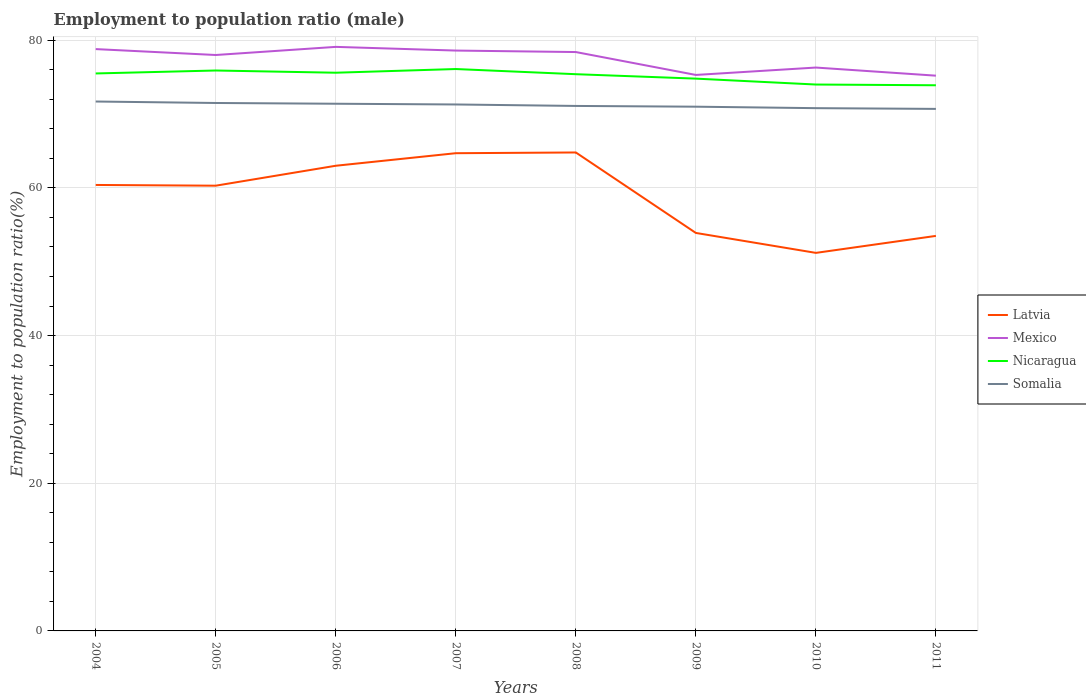Is the number of lines equal to the number of legend labels?
Your response must be concise. Yes. Across all years, what is the maximum employment to population ratio in Mexico?
Provide a succinct answer. 75.2. In which year was the employment to population ratio in Mexico maximum?
Offer a terse response. 2011. What is the total employment to population ratio in Somalia in the graph?
Provide a short and direct response. 0.3. What is the difference between the highest and the second highest employment to population ratio in Nicaragua?
Make the answer very short. 2.2. What is the difference between the highest and the lowest employment to population ratio in Mexico?
Provide a succinct answer. 5. Is the employment to population ratio in Mexico strictly greater than the employment to population ratio in Nicaragua over the years?
Give a very brief answer. No. What is the difference between two consecutive major ticks on the Y-axis?
Ensure brevity in your answer.  20. Are the values on the major ticks of Y-axis written in scientific E-notation?
Keep it short and to the point. No. Does the graph contain any zero values?
Provide a succinct answer. No. Where does the legend appear in the graph?
Offer a terse response. Center right. How are the legend labels stacked?
Provide a short and direct response. Vertical. What is the title of the graph?
Your response must be concise. Employment to population ratio (male). Does "Korea (Republic)" appear as one of the legend labels in the graph?
Give a very brief answer. No. What is the label or title of the Y-axis?
Offer a terse response. Employment to population ratio(%). What is the Employment to population ratio(%) of Latvia in 2004?
Ensure brevity in your answer.  60.4. What is the Employment to population ratio(%) of Mexico in 2004?
Keep it short and to the point. 78.8. What is the Employment to population ratio(%) of Nicaragua in 2004?
Offer a terse response. 75.5. What is the Employment to population ratio(%) in Somalia in 2004?
Provide a succinct answer. 71.7. What is the Employment to population ratio(%) of Latvia in 2005?
Keep it short and to the point. 60.3. What is the Employment to population ratio(%) of Nicaragua in 2005?
Provide a succinct answer. 75.9. What is the Employment to population ratio(%) of Somalia in 2005?
Offer a very short reply. 71.5. What is the Employment to population ratio(%) in Latvia in 2006?
Provide a succinct answer. 63. What is the Employment to population ratio(%) of Mexico in 2006?
Your answer should be very brief. 79.1. What is the Employment to population ratio(%) in Nicaragua in 2006?
Your answer should be very brief. 75.6. What is the Employment to population ratio(%) of Somalia in 2006?
Keep it short and to the point. 71.4. What is the Employment to population ratio(%) of Latvia in 2007?
Your answer should be compact. 64.7. What is the Employment to population ratio(%) in Mexico in 2007?
Provide a short and direct response. 78.6. What is the Employment to population ratio(%) in Nicaragua in 2007?
Offer a terse response. 76.1. What is the Employment to population ratio(%) in Somalia in 2007?
Your response must be concise. 71.3. What is the Employment to population ratio(%) in Latvia in 2008?
Provide a short and direct response. 64.8. What is the Employment to population ratio(%) of Mexico in 2008?
Keep it short and to the point. 78.4. What is the Employment to population ratio(%) of Nicaragua in 2008?
Offer a terse response. 75.4. What is the Employment to population ratio(%) in Somalia in 2008?
Your response must be concise. 71.1. What is the Employment to population ratio(%) in Latvia in 2009?
Make the answer very short. 53.9. What is the Employment to population ratio(%) in Mexico in 2009?
Offer a very short reply. 75.3. What is the Employment to population ratio(%) of Nicaragua in 2009?
Your response must be concise. 74.8. What is the Employment to population ratio(%) in Somalia in 2009?
Your response must be concise. 71. What is the Employment to population ratio(%) in Latvia in 2010?
Ensure brevity in your answer.  51.2. What is the Employment to population ratio(%) in Mexico in 2010?
Your response must be concise. 76.3. What is the Employment to population ratio(%) of Somalia in 2010?
Give a very brief answer. 70.8. What is the Employment to population ratio(%) in Latvia in 2011?
Your answer should be compact. 53.5. What is the Employment to population ratio(%) of Mexico in 2011?
Your answer should be compact. 75.2. What is the Employment to population ratio(%) of Nicaragua in 2011?
Offer a very short reply. 73.9. What is the Employment to population ratio(%) of Somalia in 2011?
Provide a short and direct response. 70.7. Across all years, what is the maximum Employment to population ratio(%) of Latvia?
Your answer should be compact. 64.8. Across all years, what is the maximum Employment to population ratio(%) of Mexico?
Give a very brief answer. 79.1. Across all years, what is the maximum Employment to population ratio(%) in Nicaragua?
Give a very brief answer. 76.1. Across all years, what is the maximum Employment to population ratio(%) of Somalia?
Your answer should be compact. 71.7. Across all years, what is the minimum Employment to population ratio(%) of Latvia?
Give a very brief answer. 51.2. Across all years, what is the minimum Employment to population ratio(%) of Mexico?
Your answer should be compact. 75.2. Across all years, what is the minimum Employment to population ratio(%) in Nicaragua?
Your answer should be compact. 73.9. Across all years, what is the minimum Employment to population ratio(%) of Somalia?
Make the answer very short. 70.7. What is the total Employment to population ratio(%) of Latvia in the graph?
Your answer should be compact. 471.8. What is the total Employment to population ratio(%) in Mexico in the graph?
Ensure brevity in your answer.  619.7. What is the total Employment to population ratio(%) in Nicaragua in the graph?
Offer a very short reply. 601.2. What is the total Employment to population ratio(%) of Somalia in the graph?
Your answer should be compact. 569.5. What is the difference between the Employment to population ratio(%) of Latvia in 2004 and that in 2005?
Ensure brevity in your answer.  0.1. What is the difference between the Employment to population ratio(%) of Mexico in 2004 and that in 2005?
Your answer should be compact. 0.8. What is the difference between the Employment to population ratio(%) of Nicaragua in 2004 and that in 2005?
Provide a short and direct response. -0.4. What is the difference between the Employment to population ratio(%) of Somalia in 2004 and that in 2005?
Offer a very short reply. 0.2. What is the difference between the Employment to population ratio(%) in Nicaragua in 2004 and that in 2006?
Your answer should be very brief. -0.1. What is the difference between the Employment to population ratio(%) in Somalia in 2004 and that in 2006?
Make the answer very short. 0.3. What is the difference between the Employment to population ratio(%) of Nicaragua in 2004 and that in 2007?
Make the answer very short. -0.6. What is the difference between the Employment to population ratio(%) in Somalia in 2004 and that in 2007?
Your answer should be very brief. 0.4. What is the difference between the Employment to population ratio(%) in Somalia in 2004 and that in 2008?
Make the answer very short. 0.6. What is the difference between the Employment to population ratio(%) in Nicaragua in 2004 and that in 2009?
Make the answer very short. 0.7. What is the difference between the Employment to population ratio(%) in Latvia in 2004 and that in 2010?
Your response must be concise. 9.2. What is the difference between the Employment to population ratio(%) of Nicaragua in 2004 and that in 2010?
Your answer should be compact. 1.5. What is the difference between the Employment to population ratio(%) in Latvia in 2005 and that in 2006?
Your answer should be compact. -2.7. What is the difference between the Employment to population ratio(%) in Somalia in 2005 and that in 2006?
Keep it short and to the point. 0.1. What is the difference between the Employment to population ratio(%) of Latvia in 2005 and that in 2007?
Offer a very short reply. -4.4. What is the difference between the Employment to population ratio(%) in Nicaragua in 2005 and that in 2007?
Offer a very short reply. -0.2. What is the difference between the Employment to population ratio(%) in Somalia in 2005 and that in 2007?
Provide a succinct answer. 0.2. What is the difference between the Employment to population ratio(%) of Latvia in 2005 and that in 2008?
Your response must be concise. -4.5. What is the difference between the Employment to population ratio(%) in Mexico in 2005 and that in 2008?
Make the answer very short. -0.4. What is the difference between the Employment to population ratio(%) in Nicaragua in 2005 and that in 2008?
Your response must be concise. 0.5. What is the difference between the Employment to population ratio(%) of Mexico in 2005 and that in 2010?
Your answer should be very brief. 1.7. What is the difference between the Employment to population ratio(%) of Somalia in 2005 and that in 2010?
Keep it short and to the point. 0.7. What is the difference between the Employment to population ratio(%) of Latvia in 2005 and that in 2011?
Give a very brief answer. 6.8. What is the difference between the Employment to population ratio(%) of Nicaragua in 2005 and that in 2011?
Keep it short and to the point. 2. What is the difference between the Employment to population ratio(%) in Nicaragua in 2006 and that in 2007?
Ensure brevity in your answer.  -0.5. What is the difference between the Employment to population ratio(%) in Latvia in 2006 and that in 2008?
Offer a very short reply. -1.8. What is the difference between the Employment to population ratio(%) in Mexico in 2006 and that in 2008?
Ensure brevity in your answer.  0.7. What is the difference between the Employment to population ratio(%) of Somalia in 2006 and that in 2008?
Make the answer very short. 0.3. What is the difference between the Employment to population ratio(%) of Mexico in 2006 and that in 2009?
Ensure brevity in your answer.  3.8. What is the difference between the Employment to population ratio(%) of Nicaragua in 2006 and that in 2009?
Ensure brevity in your answer.  0.8. What is the difference between the Employment to population ratio(%) in Mexico in 2006 and that in 2010?
Provide a short and direct response. 2.8. What is the difference between the Employment to population ratio(%) of Nicaragua in 2006 and that in 2010?
Ensure brevity in your answer.  1.6. What is the difference between the Employment to population ratio(%) in Nicaragua in 2006 and that in 2011?
Give a very brief answer. 1.7. What is the difference between the Employment to population ratio(%) of Somalia in 2006 and that in 2011?
Provide a short and direct response. 0.7. What is the difference between the Employment to population ratio(%) of Latvia in 2007 and that in 2008?
Your answer should be very brief. -0.1. What is the difference between the Employment to population ratio(%) of Mexico in 2007 and that in 2008?
Ensure brevity in your answer.  0.2. What is the difference between the Employment to population ratio(%) of Somalia in 2007 and that in 2009?
Give a very brief answer. 0.3. What is the difference between the Employment to population ratio(%) in Mexico in 2007 and that in 2010?
Offer a very short reply. 2.3. What is the difference between the Employment to population ratio(%) in Latvia in 2007 and that in 2011?
Keep it short and to the point. 11.2. What is the difference between the Employment to population ratio(%) in Nicaragua in 2007 and that in 2011?
Make the answer very short. 2.2. What is the difference between the Employment to population ratio(%) of Mexico in 2008 and that in 2009?
Your response must be concise. 3.1. What is the difference between the Employment to population ratio(%) in Somalia in 2008 and that in 2009?
Provide a short and direct response. 0.1. What is the difference between the Employment to population ratio(%) of Latvia in 2008 and that in 2010?
Provide a short and direct response. 13.6. What is the difference between the Employment to population ratio(%) in Mexico in 2008 and that in 2010?
Give a very brief answer. 2.1. What is the difference between the Employment to population ratio(%) in Nicaragua in 2008 and that in 2010?
Offer a very short reply. 1.4. What is the difference between the Employment to population ratio(%) in Somalia in 2008 and that in 2010?
Your answer should be compact. 0.3. What is the difference between the Employment to population ratio(%) of Nicaragua in 2008 and that in 2011?
Provide a short and direct response. 1.5. What is the difference between the Employment to population ratio(%) of Somalia in 2008 and that in 2011?
Your response must be concise. 0.4. What is the difference between the Employment to population ratio(%) of Latvia in 2009 and that in 2010?
Keep it short and to the point. 2.7. What is the difference between the Employment to population ratio(%) in Nicaragua in 2009 and that in 2010?
Make the answer very short. 0.8. What is the difference between the Employment to population ratio(%) of Latvia in 2009 and that in 2011?
Ensure brevity in your answer.  0.4. What is the difference between the Employment to population ratio(%) of Mexico in 2009 and that in 2011?
Offer a terse response. 0.1. What is the difference between the Employment to population ratio(%) of Latvia in 2010 and that in 2011?
Your answer should be compact. -2.3. What is the difference between the Employment to population ratio(%) in Nicaragua in 2010 and that in 2011?
Provide a short and direct response. 0.1. What is the difference between the Employment to population ratio(%) in Latvia in 2004 and the Employment to population ratio(%) in Mexico in 2005?
Offer a very short reply. -17.6. What is the difference between the Employment to population ratio(%) in Latvia in 2004 and the Employment to population ratio(%) in Nicaragua in 2005?
Give a very brief answer. -15.5. What is the difference between the Employment to population ratio(%) of Latvia in 2004 and the Employment to population ratio(%) of Somalia in 2005?
Your answer should be very brief. -11.1. What is the difference between the Employment to population ratio(%) in Mexico in 2004 and the Employment to population ratio(%) in Nicaragua in 2005?
Keep it short and to the point. 2.9. What is the difference between the Employment to population ratio(%) of Latvia in 2004 and the Employment to population ratio(%) of Mexico in 2006?
Your answer should be compact. -18.7. What is the difference between the Employment to population ratio(%) of Latvia in 2004 and the Employment to population ratio(%) of Nicaragua in 2006?
Give a very brief answer. -15.2. What is the difference between the Employment to population ratio(%) in Latvia in 2004 and the Employment to population ratio(%) in Mexico in 2007?
Your response must be concise. -18.2. What is the difference between the Employment to population ratio(%) of Latvia in 2004 and the Employment to population ratio(%) of Nicaragua in 2007?
Provide a short and direct response. -15.7. What is the difference between the Employment to population ratio(%) of Latvia in 2004 and the Employment to population ratio(%) of Somalia in 2007?
Provide a succinct answer. -10.9. What is the difference between the Employment to population ratio(%) of Mexico in 2004 and the Employment to population ratio(%) of Nicaragua in 2007?
Offer a terse response. 2.7. What is the difference between the Employment to population ratio(%) in Mexico in 2004 and the Employment to population ratio(%) in Somalia in 2007?
Offer a very short reply. 7.5. What is the difference between the Employment to population ratio(%) of Nicaragua in 2004 and the Employment to population ratio(%) of Somalia in 2007?
Your answer should be compact. 4.2. What is the difference between the Employment to population ratio(%) in Latvia in 2004 and the Employment to population ratio(%) in Nicaragua in 2008?
Keep it short and to the point. -15. What is the difference between the Employment to population ratio(%) of Latvia in 2004 and the Employment to population ratio(%) of Somalia in 2008?
Keep it short and to the point. -10.7. What is the difference between the Employment to population ratio(%) of Mexico in 2004 and the Employment to population ratio(%) of Somalia in 2008?
Ensure brevity in your answer.  7.7. What is the difference between the Employment to population ratio(%) of Nicaragua in 2004 and the Employment to population ratio(%) of Somalia in 2008?
Keep it short and to the point. 4.4. What is the difference between the Employment to population ratio(%) of Latvia in 2004 and the Employment to population ratio(%) of Mexico in 2009?
Your answer should be very brief. -14.9. What is the difference between the Employment to population ratio(%) of Latvia in 2004 and the Employment to population ratio(%) of Nicaragua in 2009?
Offer a very short reply. -14.4. What is the difference between the Employment to population ratio(%) of Latvia in 2004 and the Employment to population ratio(%) of Mexico in 2010?
Provide a short and direct response. -15.9. What is the difference between the Employment to population ratio(%) in Latvia in 2004 and the Employment to population ratio(%) in Somalia in 2010?
Provide a succinct answer. -10.4. What is the difference between the Employment to population ratio(%) in Mexico in 2004 and the Employment to population ratio(%) in Somalia in 2010?
Keep it short and to the point. 8. What is the difference between the Employment to population ratio(%) in Nicaragua in 2004 and the Employment to population ratio(%) in Somalia in 2010?
Provide a succinct answer. 4.7. What is the difference between the Employment to population ratio(%) in Latvia in 2004 and the Employment to population ratio(%) in Mexico in 2011?
Give a very brief answer. -14.8. What is the difference between the Employment to population ratio(%) in Latvia in 2004 and the Employment to population ratio(%) in Nicaragua in 2011?
Give a very brief answer. -13.5. What is the difference between the Employment to population ratio(%) of Mexico in 2004 and the Employment to population ratio(%) of Nicaragua in 2011?
Offer a terse response. 4.9. What is the difference between the Employment to population ratio(%) of Mexico in 2004 and the Employment to population ratio(%) of Somalia in 2011?
Your answer should be compact. 8.1. What is the difference between the Employment to population ratio(%) of Latvia in 2005 and the Employment to population ratio(%) of Mexico in 2006?
Keep it short and to the point. -18.8. What is the difference between the Employment to population ratio(%) of Latvia in 2005 and the Employment to population ratio(%) of Nicaragua in 2006?
Make the answer very short. -15.3. What is the difference between the Employment to population ratio(%) in Latvia in 2005 and the Employment to population ratio(%) in Somalia in 2006?
Your answer should be compact. -11.1. What is the difference between the Employment to population ratio(%) in Mexico in 2005 and the Employment to population ratio(%) in Somalia in 2006?
Provide a succinct answer. 6.6. What is the difference between the Employment to population ratio(%) of Nicaragua in 2005 and the Employment to population ratio(%) of Somalia in 2006?
Your answer should be very brief. 4.5. What is the difference between the Employment to population ratio(%) of Latvia in 2005 and the Employment to population ratio(%) of Mexico in 2007?
Provide a succinct answer. -18.3. What is the difference between the Employment to population ratio(%) of Latvia in 2005 and the Employment to population ratio(%) of Nicaragua in 2007?
Your answer should be very brief. -15.8. What is the difference between the Employment to population ratio(%) of Mexico in 2005 and the Employment to population ratio(%) of Nicaragua in 2007?
Offer a terse response. 1.9. What is the difference between the Employment to population ratio(%) of Mexico in 2005 and the Employment to population ratio(%) of Somalia in 2007?
Keep it short and to the point. 6.7. What is the difference between the Employment to population ratio(%) in Latvia in 2005 and the Employment to population ratio(%) in Mexico in 2008?
Provide a short and direct response. -18.1. What is the difference between the Employment to population ratio(%) of Latvia in 2005 and the Employment to population ratio(%) of Nicaragua in 2008?
Your answer should be very brief. -15.1. What is the difference between the Employment to population ratio(%) in Latvia in 2005 and the Employment to population ratio(%) in Somalia in 2008?
Provide a short and direct response. -10.8. What is the difference between the Employment to population ratio(%) in Mexico in 2005 and the Employment to population ratio(%) in Nicaragua in 2008?
Offer a very short reply. 2.6. What is the difference between the Employment to population ratio(%) in Latvia in 2005 and the Employment to population ratio(%) in Mexico in 2009?
Provide a succinct answer. -15. What is the difference between the Employment to population ratio(%) of Latvia in 2005 and the Employment to population ratio(%) of Nicaragua in 2009?
Offer a very short reply. -14.5. What is the difference between the Employment to population ratio(%) in Mexico in 2005 and the Employment to population ratio(%) in Nicaragua in 2009?
Your answer should be very brief. 3.2. What is the difference between the Employment to population ratio(%) in Nicaragua in 2005 and the Employment to population ratio(%) in Somalia in 2009?
Offer a very short reply. 4.9. What is the difference between the Employment to population ratio(%) of Latvia in 2005 and the Employment to population ratio(%) of Nicaragua in 2010?
Your answer should be compact. -13.7. What is the difference between the Employment to population ratio(%) of Mexico in 2005 and the Employment to population ratio(%) of Nicaragua in 2010?
Offer a terse response. 4. What is the difference between the Employment to population ratio(%) of Latvia in 2005 and the Employment to population ratio(%) of Mexico in 2011?
Provide a succinct answer. -14.9. What is the difference between the Employment to population ratio(%) of Mexico in 2005 and the Employment to population ratio(%) of Nicaragua in 2011?
Keep it short and to the point. 4.1. What is the difference between the Employment to population ratio(%) of Latvia in 2006 and the Employment to population ratio(%) of Mexico in 2007?
Your answer should be compact. -15.6. What is the difference between the Employment to population ratio(%) in Latvia in 2006 and the Employment to population ratio(%) in Nicaragua in 2007?
Give a very brief answer. -13.1. What is the difference between the Employment to population ratio(%) in Latvia in 2006 and the Employment to population ratio(%) in Somalia in 2007?
Make the answer very short. -8.3. What is the difference between the Employment to population ratio(%) in Mexico in 2006 and the Employment to population ratio(%) in Nicaragua in 2007?
Your response must be concise. 3. What is the difference between the Employment to population ratio(%) of Mexico in 2006 and the Employment to population ratio(%) of Somalia in 2007?
Offer a terse response. 7.8. What is the difference between the Employment to population ratio(%) of Latvia in 2006 and the Employment to population ratio(%) of Mexico in 2008?
Your response must be concise. -15.4. What is the difference between the Employment to population ratio(%) of Latvia in 2006 and the Employment to population ratio(%) of Nicaragua in 2008?
Your answer should be compact. -12.4. What is the difference between the Employment to population ratio(%) in Latvia in 2006 and the Employment to population ratio(%) in Somalia in 2008?
Ensure brevity in your answer.  -8.1. What is the difference between the Employment to population ratio(%) in Mexico in 2006 and the Employment to population ratio(%) in Somalia in 2008?
Give a very brief answer. 8. What is the difference between the Employment to population ratio(%) in Latvia in 2006 and the Employment to population ratio(%) in Mexico in 2009?
Your answer should be compact. -12.3. What is the difference between the Employment to population ratio(%) of Latvia in 2006 and the Employment to population ratio(%) of Nicaragua in 2009?
Offer a terse response. -11.8. What is the difference between the Employment to population ratio(%) in Nicaragua in 2006 and the Employment to population ratio(%) in Somalia in 2009?
Provide a short and direct response. 4.6. What is the difference between the Employment to population ratio(%) of Latvia in 2006 and the Employment to population ratio(%) of Mexico in 2010?
Your response must be concise. -13.3. What is the difference between the Employment to population ratio(%) of Latvia in 2006 and the Employment to population ratio(%) of Nicaragua in 2010?
Provide a succinct answer. -11. What is the difference between the Employment to population ratio(%) of Mexico in 2006 and the Employment to population ratio(%) of Nicaragua in 2010?
Ensure brevity in your answer.  5.1. What is the difference between the Employment to population ratio(%) of Nicaragua in 2006 and the Employment to population ratio(%) of Somalia in 2010?
Provide a succinct answer. 4.8. What is the difference between the Employment to population ratio(%) in Latvia in 2006 and the Employment to population ratio(%) in Nicaragua in 2011?
Your answer should be very brief. -10.9. What is the difference between the Employment to population ratio(%) in Mexico in 2006 and the Employment to population ratio(%) in Nicaragua in 2011?
Provide a short and direct response. 5.2. What is the difference between the Employment to population ratio(%) in Mexico in 2006 and the Employment to population ratio(%) in Somalia in 2011?
Provide a short and direct response. 8.4. What is the difference between the Employment to population ratio(%) of Nicaragua in 2006 and the Employment to population ratio(%) of Somalia in 2011?
Ensure brevity in your answer.  4.9. What is the difference between the Employment to population ratio(%) in Latvia in 2007 and the Employment to population ratio(%) in Mexico in 2008?
Your answer should be compact. -13.7. What is the difference between the Employment to population ratio(%) in Mexico in 2007 and the Employment to population ratio(%) in Nicaragua in 2008?
Provide a succinct answer. 3.2. What is the difference between the Employment to population ratio(%) in Latvia in 2007 and the Employment to population ratio(%) in Mexico in 2009?
Keep it short and to the point. -10.6. What is the difference between the Employment to population ratio(%) of Latvia in 2007 and the Employment to population ratio(%) of Nicaragua in 2009?
Give a very brief answer. -10.1. What is the difference between the Employment to population ratio(%) in Latvia in 2007 and the Employment to population ratio(%) in Somalia in 2009?
Your answer should be very brief. -6.3. What is the difference between the Employment to population ratio(%) of Mexico in 2007 and the Employment to population ratio(%) of Nicaragua in 2009?
Ensure brevity in your answer.  3.8. What is the difference between the Employment to population ratio(%) in Nicaragua in 2007 and the Employment to population ratio(%) in Somalia in 2009?
Your answer should be very brief. 5.1. What is the difference between the Employment to population ratio(%) in Mexico in 2007 and the Employment to population ratio(%) in Nicaragua in 2010?
Your answer should be very brief. 4.6. What is the difference between the Employment to population ratio(%) of Latvia in 2007 and the Employment to population ratio(%) of Mexico in 2011?
Your response must be concise. -10.5. What is the difference between the Employment to population ratio(%) in Latvia in 2007 and the Employment to population ratio(%) in Somalia in 2011?
Make the answer very short. -6. What is the difference between the Employment to population ratio(%) of Nicaragua in 2007 and the Employment to population ratio(%) of Somalia in 2011?
Provide a succinct answer. 5.4. What is the difference between the Employment to population ratio(%) of Latvia in 2008 and the Employment to population ratio(%) of Nicaragua in 2009?
Offer a terse response. -10. What is the difference between the Employment to population ratio(%) in Latvia in 2008 and the Employment to population ratio(%) in Somalia in 2009?
Offer a very short reply. -6.2. What is the difference between the Employment to population ratio(%) in Mexico in 2008 and the Employment to population ratio(%) in Nicaragua in 2009?
Make the answer very short. 3.6. What is the difference between the Employment to population ratio(%) in Mexico in 2008 and the Employment to population ratio(%) in Somalia in 2009?
Give a very brief answer. 7.4. What is the difference between the Employment to population ratio(%) in Latvia in 2008 and the Employment to population ratio(%) in Somalia in 2010?
Provide a succinct answer. -6. What is the difference between the Employment to population ratio(%) of Mexico in 2008 and the Employment to population ratio(%) of Nicaragua in 2010?
Ensure brevity in your answer.  4.4. What is the difference between the Employment to population ratio(%) of Mexico in 2008 and the Employment to population ratio(%) of Somalia in 2010?
Keep it short and to the point. 7.6. What is the difference between the Employment to population ratio(%) in Latvia in 2008 and the Employment to population ratio(%) in Mexico in 2011?
Provide a short and direct response. -10.4. What is the difference between the Employment to population ratio(%) in Latvia in 2008 and the Employment to population ratio(%) in Nicaragua in 2011?
Keep it short and to the point. -9.1. What is the difference between the Employment to population ratio(%) of Mexico in 2008 and the Employment to population ratio(%) of Nicaragua in 2011?
Your answer should be very brief. 4.5. What is the difference between the Employment to population ratio(%) in Mexico in 2008 and the Employment to population ratio(%) in Somalia in 2011?
Your answer should be compact. 7.7. What is the difference between the Employment to population ratio(%) in Nicaragua in 2008 and the Employment to population ratio(%) in Somalia in 2011?
Keep it short and to the point. 4.7. What is the difference between the Employment to population ratio(%) of Latvia in 2009 and the Employment to population ratio(%) of Mexico in 2010?
Give a very brief answer. -22.4. What is the difference between the Employment to population ratio(%) in Latvia in 2009 and the Employment to population ratio(%) in Nicaragua in 2010?
Keep it short and to the point. -20.1. What is the difference between the Employment to population ratio(%) of Latvia in 2009 and the Employment to population ratio(%) of Somalia in 2010?
Your response must be concise. -16.9. What is the difference between the Employment to population ratio(%) of Mexico in 2009 and the Employment to population ratio(%) of Somalia in 2010?
Your answer should be compact. 4.5. What is the difference between the Employment to population ratio(%) in Latvia in 2009 and the Employment to population ratio(%) in Mexico in 2011?
Give a very brief answer. -21.3. What is the difference between the Employment to population ratio(%) in Latvia in 2009 and the Employment to population ratio(%) in Somalia in 2011?
Keep it short and to the point. -16.8. What is the difference between the Employment to population ratio(%) in Mexico in 2009 and the Employment to population ratio(%) in Somalia in 2011?
Offer a very short reply. 4.6. What is the difference between the Employment to population ratio(%) of Nicaragua in 2009 and the Employment to population ratio(%) of Somalia in 2011?
Ensure brevity in your answer.  4.1. What is the difference between the Employment to population ratio(%) of Latvia in 2010 and the Employment to population ratio(%) of Nicaragua in 2011?
Offer a very short reply. -22.7. What is the difference between the Employment to population ratio(%) of Latvia in 2010 and the Employment to population ratio(%) of Somalia in 2011?
Keep it short and to the point. -19.5. What is the difference between the Employment to population ratio(%) in Mexico in 2010 and the Employment to population ratio(%) in Nicaragua in 2011?
Provide a succinct answer. 2.4. What is the difference between the Employment to population ratio(%) in Mexico in 2010 and the Employment to population ratio(%) in Somalia in 2011?
Keep it short and to the point. 5.6. What is the difference between the Employment to population ratio(%) in Nicaragua in 2010 and the Employment to population ratio(%) in Somalia in 2011?
Offer a terse response. 3.3. What is the average Employment to population ratio(%) of Latvia per year?
Offer a terse response. 58.98. What is the average Employment to population ratio(%) of Mexico per year?
Give a very brief answer. 77.46. What is the average Employment to population ratio(%) in Nicaragua per year?
Make the answer very short. 75.15. What is the average Employment to population ratio(%) in Somalia per year?
Provide a short and direct response. 71.19. In the year 2004, what is the difference between the Employment to population ratio(%) of Latvia and Employment to population ratio(%) of Mexico?
Ensure brevity in your answer.  -18.4. In the year 2004, what is the difference between the Employment to population ratio(%) in Latvia and Employment to population ratio(%) in Nicaragua?
Provide a short and direct response. -15.1. In the year 2005, what is the difference between the Employment to population ratio(%) in Latvia and Employment to population ratio(%) in Mexico?
Your answer should be compact. -17.7. In the year 2005, what is the difference between the Employment to population ratio(%) in Latvia and Employment to population ratio(%) in Nicaragua?
Offer a very short reply. -15.6. In the year 2006, what is the difference between the Employment to population ratio(%) in Latvia and Employment to population ratio(%) in Mexico?
Ensure brevity in your answer.  -16.1. In the year 2006, what is the difference between the Employment to population ratio(%) of Latvia and Employment to population ratio(%) of Somalia?
Your answer should be compact. -8.4. In the year 2006, what is the difference between the Employment to population ratio(%) in Mexico and Employment to population ratio(%) in Somalia?
Make the answer very short. 7.7. In the year 2006, what is the difference between the Employment to population ratio(%) of Nicaragua and Employment to population ratio(%) of Somalia?
Keep it short and to the point. 4.2. In the year 2007, what is the difference between the Employment to population ratio(%) in Latvia and Employment to population ratio(%) in Mexico?
Provide a short and direct response. -13.9. In the year 2007, what is the difference between the Employment to population ratio(%) of Latvia and Employment to population ratio(%) of Nicaragua?
Provide a succinct answer. -11.4. In the year 2007, what is the difference between the Employment to population ratio(%) in Mexico and Employment to population ratio(%) in Somalia?
Provide a succinct answer. 7.3. In the year 2007, what is the difference between the Employment to population ratio(%) of Nicaragua and Employment to population ratio(%) of Somalia?
Keep it short and to the point. 4.8. In the year 2008, what is the difference between the Employment to population ratio(%) of Latvia and Employment to population ratio(%) of Nicaragua?
Offer a terse response. -10.6. In the year 2008, what is the difference between the Employment to population ratio(%) in Latvia and Employment to population ratio(%) in Somalia?
Offer a terse response. -6.3. In the year 2008, what is the difference between the Employment to population ratio(%) of Nicaragua and Employment to population ratio(%) of Somalia?
Offer a terse response. 4.3. In the year 2009, what is the difference between the Employment to population ratio(%) in Latvia and Employment to population ratio(%) in Mexico?
Give a very brief answer. -21.4. In the year 2009, what is the difference between the Employment to population ratio(%) of Latvia and Employment to population ratio(%) of Nicaragua?
Your answer should be compact. -20.9. In the year 2009, what is the difference between the Employment to population ratio(%) in Latvia and Employment to population ratio(%) in Somalia?
Make the answer very short. -17.1. In the year 2009, what is the difference between the Employment to population ratio(%) of Mexico and Employment to population ratio(%) of Somalia?
Provide a short and direct response. 4.3. In the year 2009, what is the difference between the Employment to population ratio(%) of Nicaragua and Employment to population ratio(%) of Somalia?
Your response must be concise. 3.8. In the year 2010, what is the difference between the Employment to population ratio(%) in Latvia and Employment to population ratio(%) in Mexico?
Provide a succinct answer. -25.1. In the year 2010, what is the difference between the Employment to population ratio(%) of Latvia and Employment to population ratio(%) of Nicaragua?
Provide a succinct answer. -22.8. In the year 2010, what is the difference between the Employment to population ratio(%) of Latvia and Employment to population ratio(%) of Somalia?
Provide a succinct answer. -19.6. In the year 2011, what is the difference between the Employment to population ratio(%) of Latvia and Employment to population ratio(%) of Mexico?
Your answer should be compact. -21.7. In the year 2011, what is the difference between the Employment to population ratio(%) in Latvia and Employment to population ratio(%) in Nicaragua?
Ensure brevity in your answer.  -20.4. In the year 2011, what is the difference between the Employment to population ratio(%) of Latvia and Employment to population ratio(%) of Somalia?
Provide a succinct answer. -17.2. What is the ratio of the Employment to population ratio(%) in Latvia in 2004 to that in 2005?
Offer a very short reply. 1. What is the ratio of the Employment to population ratio(%) in Mexico in 2004 to that in 2005?
Give a very brief answer. 1.01. What is the ratio of the Employment to population ratio(%) of Latvia in 2004 to that in 2006?
Make the answer very short. 0.96. What is the ratio of the Employment to population ratio(%) in Mexico in 2004 to that in 2006?
Give a very brief answer. 1. What is the ratio of the Employment to population ratio(%) in Nicaragua in 2004 to that in 2006?
Your answer should be compact. 1. What is the ratio of the Employment to population ratio(%) of Somalia in 2004 to that in 2006?
Give a very brief answer. 1. What is the ratio of the Employment to population ratio(%) in Latvia in 2004 to that in 2007?
Make the answer very short. 0.93. What is the ratio of the Employment to population ratio(%) of Somalia in 2004 to that in 2007?
Make the answer very short. 1.01. What is the ratio of the Employment to population ratio(%) in Latvia in 2004 to that in 2008?
Provide a succinct answer. 0.93. What is the ratio of the Employment to population ratio(%) in Mexico in 2004 to that in 2008?
Provide a succinct answer. 1.01. What is the ratio of the Employment to population ratio(%) of Somalia in 2004 to that in 2008?
Ensure brevity in your answer.  1.01. What is the ratio of the Employment to population ratio(%) of Latvia in 2004 to that in 2009?
Give a very brief answer. 1.12. What is the ratio of the Employment to population ratio(%) of Mexico in 2004 to that in 2009?
Your response must be concise. 1.05. What is the ratio of the Employment to population ratio(%) in Nicaragua in 2004 to that in 2009?
Provide a short and direct response. 1.01. What is the ratio of the Employment to population ratio(%) in Somalia in 2004 to that in 2009?
Keep it short and to the point. 1.01. What is the ratio of the Employment to population ratio(%) in Latvia in 2004 to that in 2010?
Your response must be concise. 1.18. What is the ratio of the Employment to population ratio(%) of Mexico in 2004 to that in 2010?
Provide a short and direct response. 1.03. What is the ratio of the Employment to population ratio(%) in Nicaragua in 2004 to that in 2010?
Offer a very short reply. 1.02. What is the ratio of the Employment to population ratio(%) in Somalia in 2004 to that in 2010?
Keep it short and to the point. 1.01. What is the ratio of the Employment to population ratio(%) of Latvia in 2004 to that in 2011?
Offer a terse response. 1.13. What is the ratio of the Employment to population ratio(%) in Mexico in 2004 to that in 2011?
Provide a short and direct response. 1.05. What is the ratio of the Employment to population ratio(%) of Nicaragua in 2004 to that in 2011?
Make the answer very short. 1.02. What is the ratio of the Employment to population ratio(%) in Somalia in 2004 to that in 2011?
Keep it short and to the point. 1.01. What is the ratio of the Employment to population ratio(%) of Latvia in 2005 to that in 2006?
Make the answer very short. 0.96. What is the ratio of the Employment to population ratio(%) of Mexico in 2005 to that in 2006?
Ensure brevity in your answer.  0.99. What is the ratio of the Employment to population ratio(%) in Latvia in 2005 to that in 2007?
Your response must be concise. 0.93. What is the ratio of the Employment to population ratio(%) in Mexico in 2005 to that in 2007?
Your answer should be compact. 0.99. What is the ratio of the Employment to population ratio(%) in Nicaragua in 2005 to that in 2007?
Offer a very short reply. 1. What is the ratio of the Employment to population ratio(%) of Latvia in 2005 to that in 2008?
Provide a short and direct response. 0.93. What is the ratio of the Employment to population ratio(%) in Nicaragua in 2005 to that in 2008?
Provide a succinct answer. 1.01. What is the ratio of the Employment to population ratio(%) in Somalia in 2005 to that in 2008?
Your response must be concise. 1.01. What is the ratio of the Employment to population ratio(%) in Latvia in 2005 to that in 2009?
Ensure brevity in your answer.  1.12. What is the ratio of the Employment to population ratio(%) in Mexico in 2005 to that in 2009?
Offer a very short reply. 1.04. What is the ratio of the Employment to population ratio(%) of Nicaragua in 2005 to that in 2009?
Make the answer very short. 1.01. What is the ratio of the Employment to population ratio(%) of Somalia in 2005 to that in 2009?
Offer a terse response. 1.01. What is the ratio of the Employment to population ratio(%) of Latvia in 2005 to that in 2010?
Offer a very short reply. 1.18. What is the ratio of the Employment to population ratio(%) of Mexico in 2005 to that in 2010?
Provide a succinct answer. 1.02. What is the ratio of the Employment to population ratio(%) in Nicaragua in 2005 to that in 2010?
Offer a terse response. 1.03. What is the ratio of the Employment to population ratio(%) of Somalia in 2005 to that in 2010?
Keep it short and to the point. 1.01. What is the ratio of the Employment to population ratio(%) in Latvia in 2005 to that in 2011?
Make the answer very short. 1.13. What is the ratio of the Employment to population ratio(%) of Mexico in 2005 to that in 2011?
Offer a very short reply. 1.04. What is the ratio of the Employment to population ratio(%) of Nicaragua in 2005 to that in 2011?
Your answer should be very brief. 1.03. What is the ratio of the Employment to population ratio(%) of Somalia in 2005 to that in 2011?
Your response must be concise. 1.01. What is the ratio of the Employment to population ratio(%) in Latvia in 2006 to that in 2007?
Provide a succinct answer. 0.97. What is the ratio of the Employment to population ratio(%) in Mexico in 2006 to that in 2007?
Ensure brevity in your answer.  1.01. What is the ratio of the Employment to population ratio(%) in Somalia in 2006 to that in 2007?
Provide a short and direct response. 1. What is the ratio of the Employment to population ratio(%) of Latvia in 2006 to that in 2008?
Give a very brief answer. 0.97. What is the ratio of the Employment to population ratio(%) of Mexico in 2006 to that in 2008?
Give a very brief answer. 1.01. What is the ratio of the Employment to population ratio(%) in Nicaragua in 2006 to that in 2008?
Provide a short and direct response. 1. What is the ratio of the Employment to population ratio(%) of Latvia in 2006 to that in 2009?
Your response must be concise. 1.17. What is the ratio of the Employment to population ratio(%) of Mexico in 2006 to that in 2009?
Offer a terse response. 1.05. What is the ratio of the Employment to population ratio(%) of Nicaragua in 2006 to that in 2009?
Provide a succinct answer. 1.01. What is the ratio of the Employment to population ratio(%) in Somalia in 2006 to that in 2009?
Give a very brief answer. 1.01. What is the ratio of the Employment to population ratio(%) of Latvia in 2006 to that in 2010?
Give a very brief answer. 1.23. What is the ratio of the Employment to population ratio(%) of Mexico in 2006 to that in 2010?
Your answer should be very brief. 1.04. What is the ratio of the Employment to population ratio(%) of Nicaragua in 2006 to that in 2010?
Offer a very short reply. 1.02. What is the ratio of the Employment to population ratio(%) in Somalia in 2006 to that in 2010?
Make the answer very short. 1.01. What is the ratio of the Employment to population ratio(%) of Latvia in 2006 to that in 2011?
Your answer should be compact. 1.18. What is the ratio of the Employment to population ratio(%) of Mexico in 2006 to that in 2011?
Give a very brief answer. 1.05. What is the ratio of the Employment to population ratio(%) in Nicaragua in 2006 to that in 2011?
Your answer should be very brief. 1.02. What is the ratio of the Employment to population ratio(%) in Somalia in 2006 to that in 2011?
Offer a very short reply. 1.01. What is the ratio of the Employment to population ratio(%) in Mexico in 2007 to that in 2008?
Your answer should be very brief. 1. What is the ratio of the Employment to population ratio(%) in Nicaragua in 2007 to that in 2008?
Your response must be concise. 1.01. What is the ratio of the Employment to population ratio(%) in Latvia in 2007 to that in 2009?
Your answer should be compact. 1.2. What is the ratio of the Employment to population ratio(%) in Mexico in 2007 to that in 2009?
Provide a succinct answer. 1.04. What is the ratio of the Employment to population ratio(%) of Nicaragua in 2007 to that in 2009?
Provide a short and direct response. 1.02. What is the ratio of the Employment to population ratio(%) in Somalia in 2007 to that in 2009?
Offer a terse response. 1. What is the ratio of the Employment to population ratio(%) of Latvia in 2007 to that in 2010?
Provide a short and direct response. 1.26. What is the ratio of the Employment to population ratio(%) of Mexico in 2007 to that in 2010?
Your answer should be very brief. 1.03. What is the ratio of the Employment to population ratio(%) of Nicaragua in 2007 to that in 2010?
Keep it short and to the point. 1.03. What is the ratio of the Employment to population ratio(%) in Somalia in 2007 to that in 2010?
Your response must be concise. 1.01. What is the ratio of the Employment to population ratio(%) in Latvia in 2007 to that in 2011?
Your answer should be compact. 1.21. What is the ratio of the Employment to population ratio(%) of Mexico in 2007 to that in 2011?
Provide a short and direct response. 1.05. What is the ratio of the Employment to population ratio(%) of Nicaragua in 2007 to that in 2011?
Your answer should be compact. 1.03. What is the ratio of the Employment to population ratio(%) in Somalia in 2007 to that in 2011?
Make the answer very short. 1.01. What is the ratio of the Employment to population ratio(%) in Latvia in 2008 to that in 2009?
Provide a short and direct response. 1.2. What is the ratio of the Employment to population ratio(%) of Mexico in 2008 to that in 2009?
Your answer should be compact. 1.04. What is the ratio of the Employment to population ratio(%) in Somalia in 2008 to that in 2009?
Provide a short and direct response. 1. What is the ratio of the Employment to population ratio(%) of Latvia in 2008 to that in 2010?
Offer a very short reply. 1.27. What is the ratio of the Employment to population ratio(%) of Mexico in 2008 to that in 2010?
Offer a very short reply. 1.03. What is the ratio of the Employment to population ratio(%) in Nicaragua in 2008 to that in 2010?
Provide a short and direct response. 1.02. What is the ratio of the Employment to population ratio(%) in Latvia in 2008 to that in 2011?
Give a very brief answer. 1.21. What is the ratio of the Employment to population ratio(%) in Mexico in 2008 to that in 2011?
Your answer should be very brief. 1.04. What is the ratio of the Employment to population ratio(%) in Nicaragua in 2008 to that in 2011?
Offer a terse response. 1.02. What is the ratio of the Employment to population ratio(%) of Latvia in 2009 to that in 2010?
Offer a very short reply. 1.05. What is the ratio of the Employment to population ratio(%) in Mexico in 2009 to that in 2010?
Provide a succinct answer. 0.99. What is the ratio of the Employment to population ratio(%) in Nicaragua in 2009 to that in 2010?
Your answer should be very brief. 1.01. What is the ratio of the Employment to population ratio(%) of Somalia in 2009 to that in 2010?
Offer a terse response. 1. What is the ratio of the Employment to population ratio(%) in Latvia in 2009 to that in 2011?
Make the answer very short. 1.01. What is the ratio of the Employment to population ratio(%) of Mexico in 2009 to that in 2011?
Offer a very short reply. 1. What is the ratio of the Employment to population ratio(%) of Nicaragua in 2009 to that in 2011?
Provide a succinct answer. 1.01. What is the ratio of the Employment to population ratio(%) of Somalia in 2009 to that in 2011?
Keep it short and to the point. 1. What is the ratio of the Employment to population ratio(%) of Mexico in 2010 to that in 2011?
Provide a short and direct response. 1.01. What is the ratio of the Employment to population ratio(%) in Nicaragua in 2010 to that in 2011?
Provide a short and direct response. 1. What is the difference between the highest and the second highest Employment to population ratio(%) of Mexico?
Keep it short and to the point. 0.3. What is the difference between the highest and the second highest Employment to population ratio(%) in Somalia?
Offer a very short reply. 0.2. What is the difference between the highest and the lowest Employment to population ratio(%) in Mexico?
Keep it short and to the point. 3.9. 